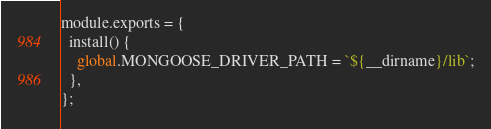<code> <loc_0><loc_0><loc_500><loc_500><_JavaScript_>module.exports = {
  install() {
    global.MONGOOSE_DRIVER_PATH = `${__dirname}/lib`;
  },
};
</code> 